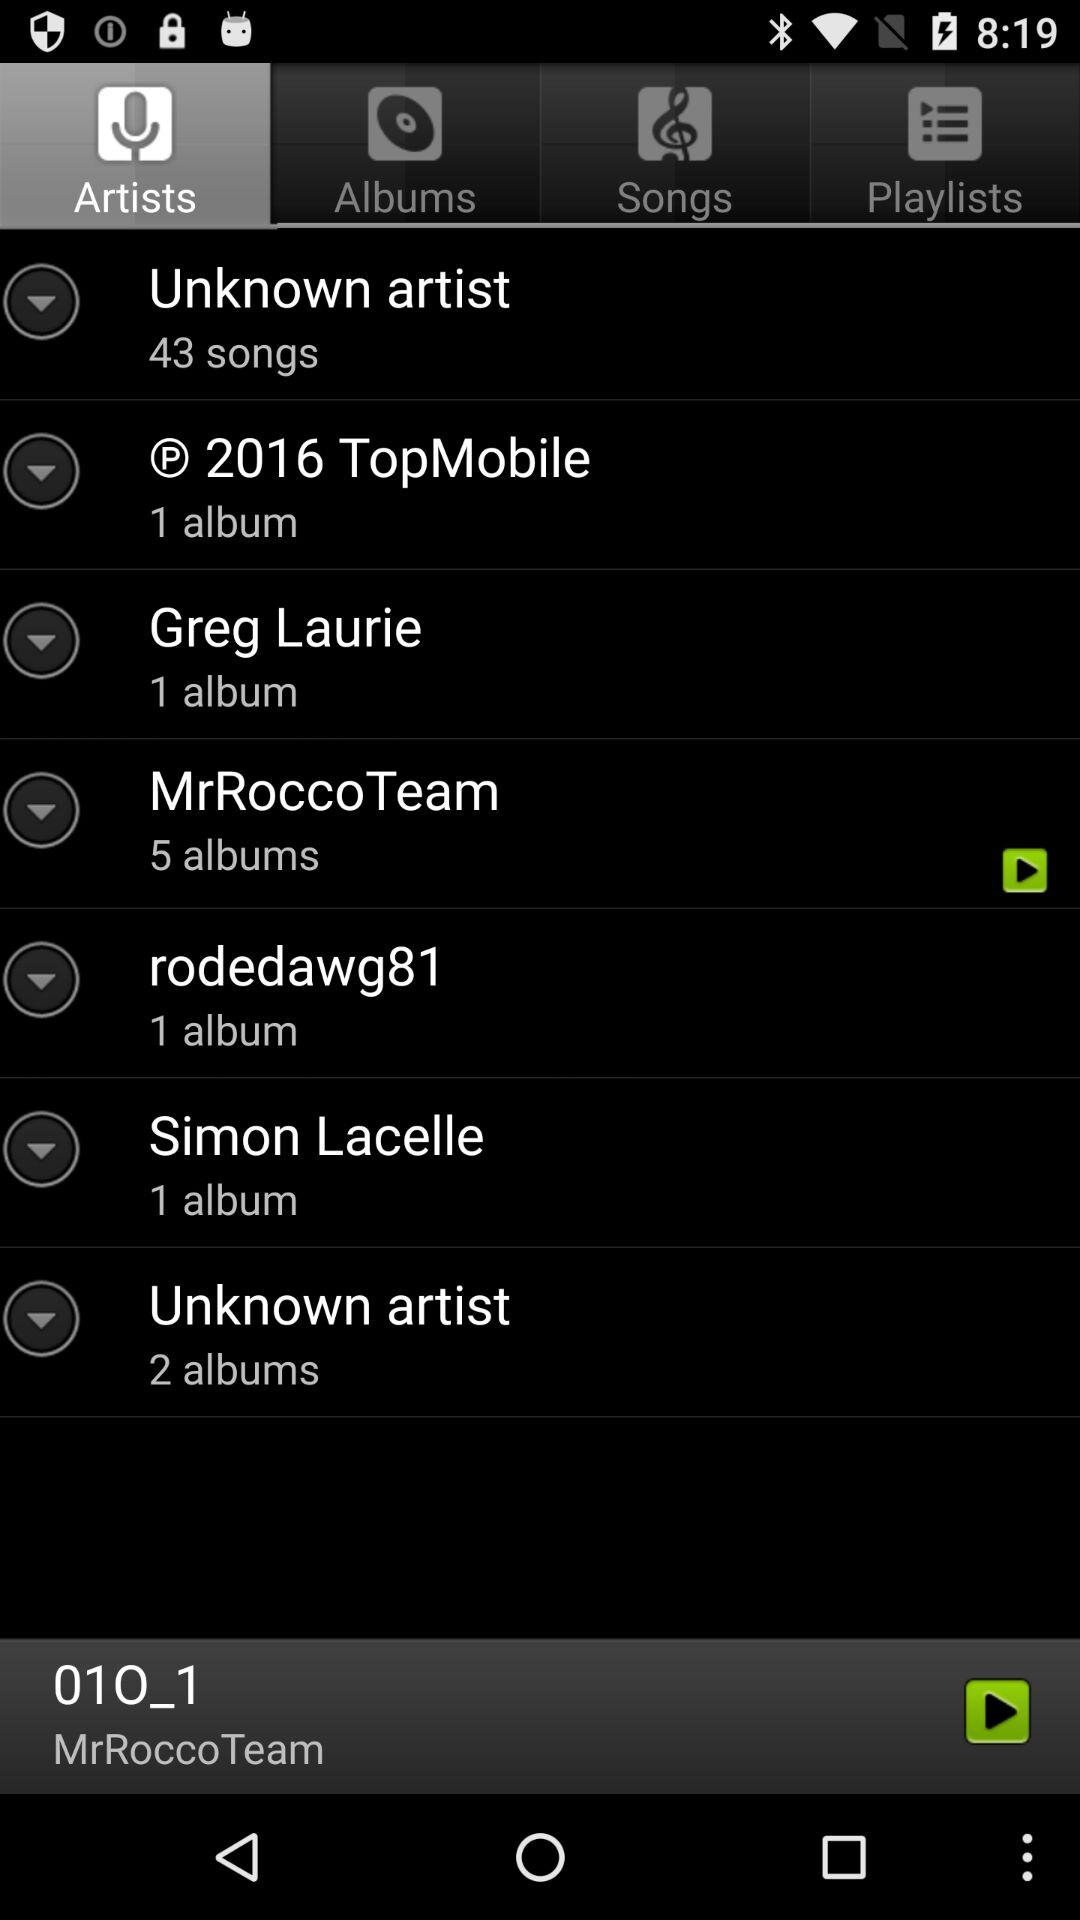How many albums are there by "MrRoccoTeam"? There are 5 albums by "MrRoccoTeam". 